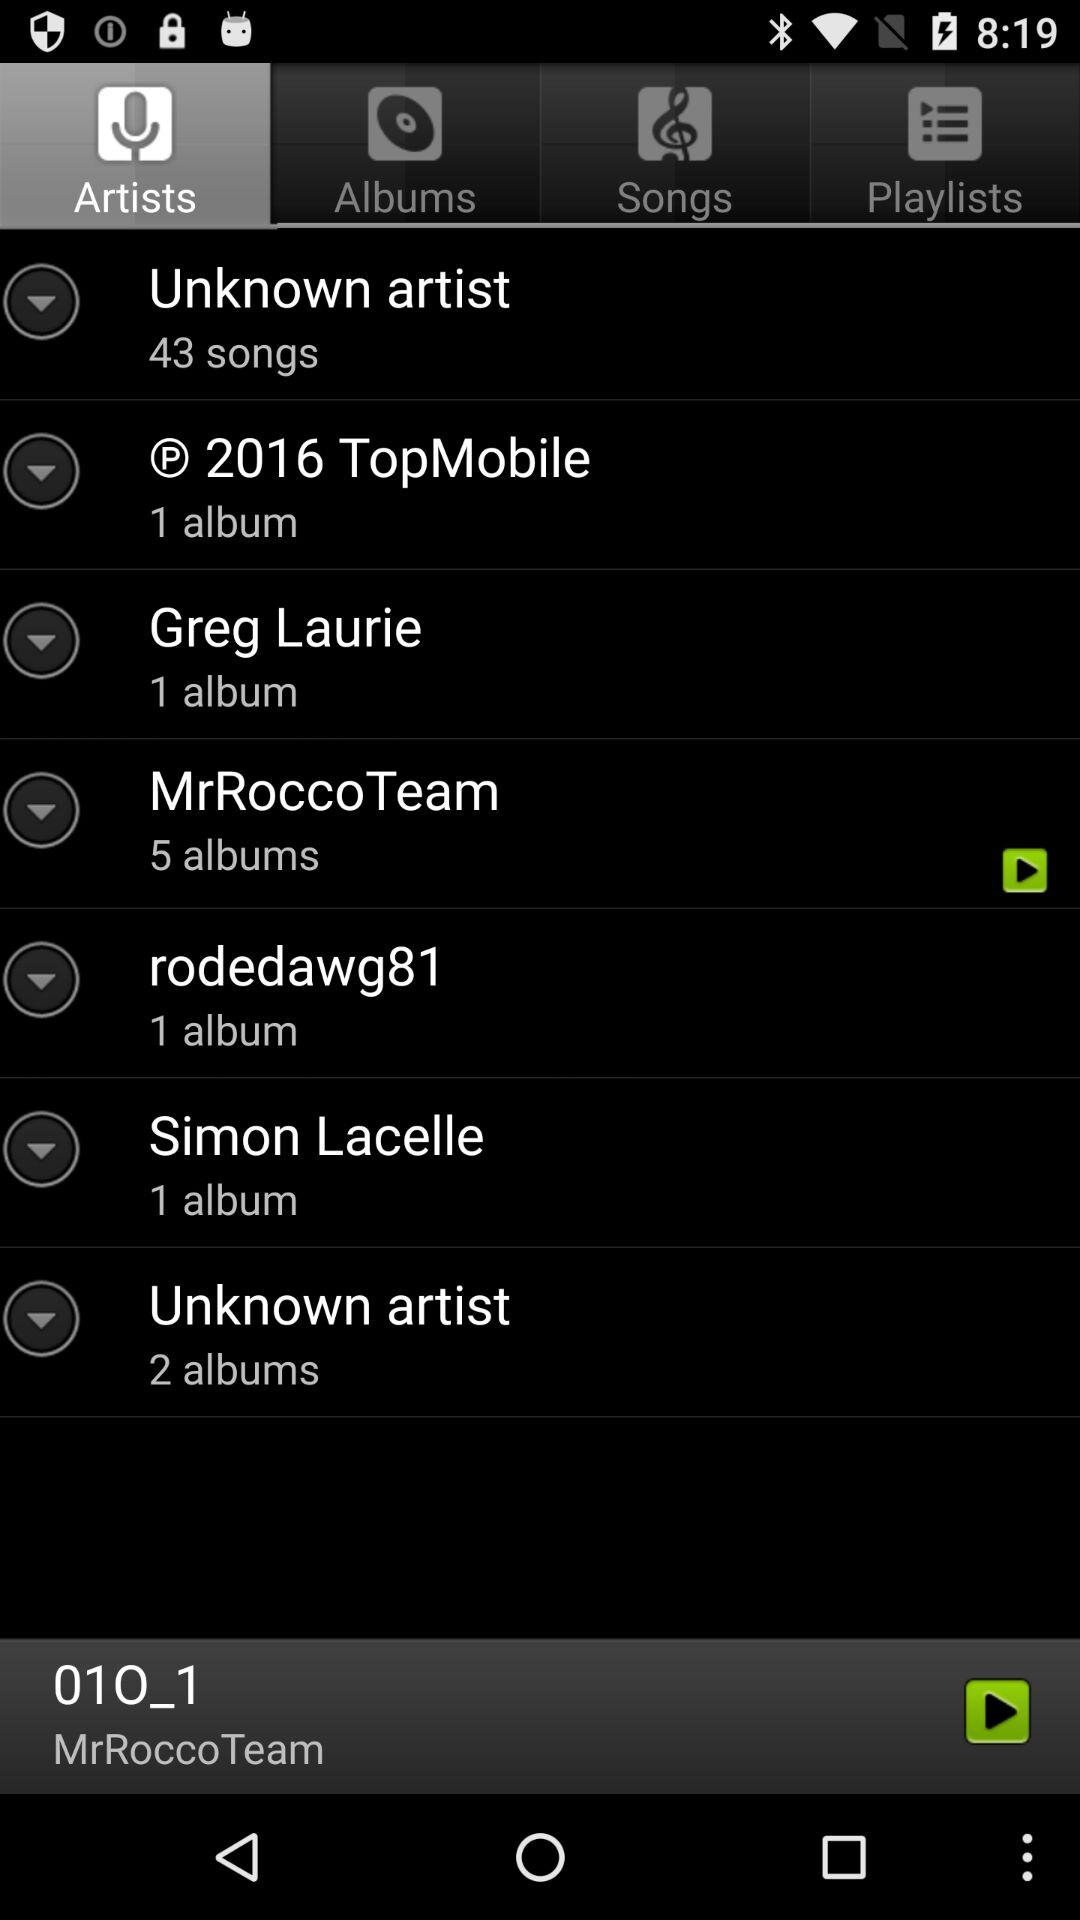How many albums are there by "MrRoccoTeam"? There are 5 albums by "MrRoccoTeam". 